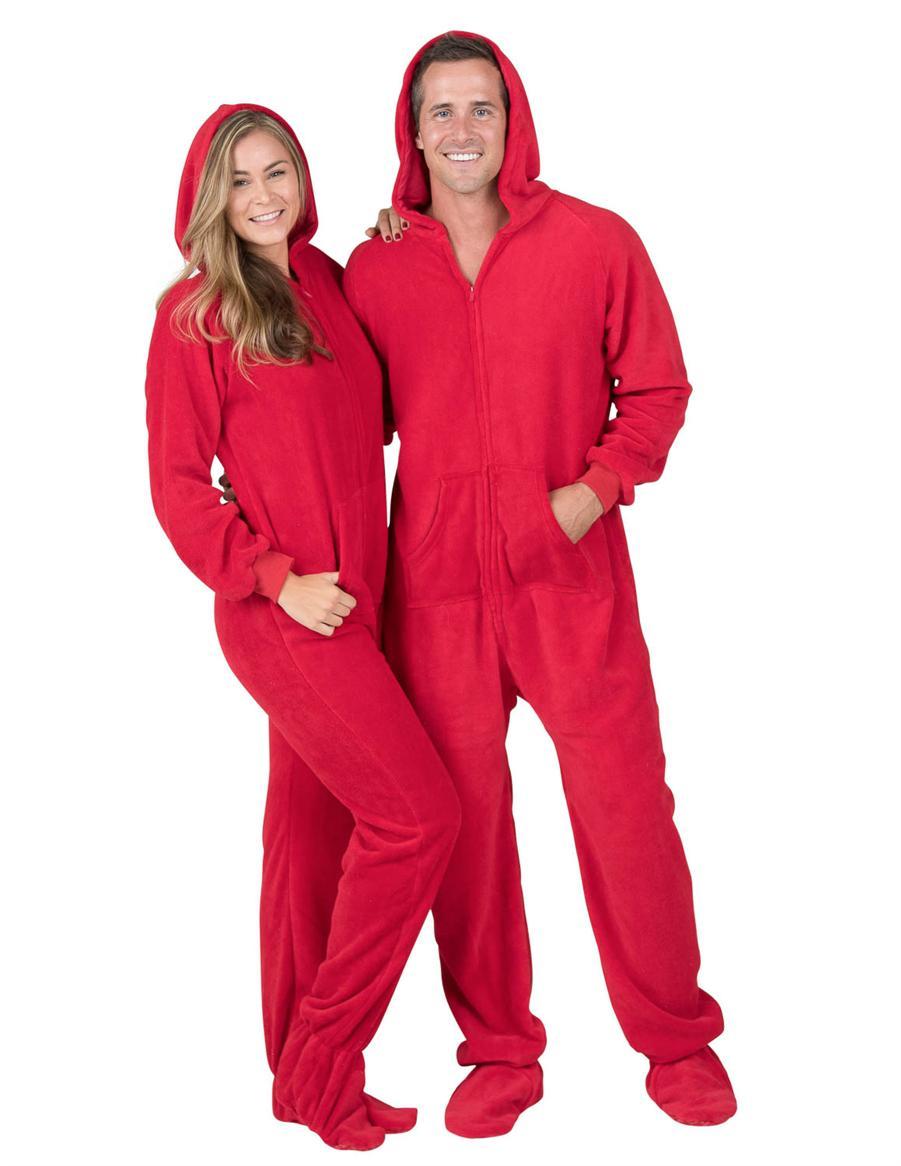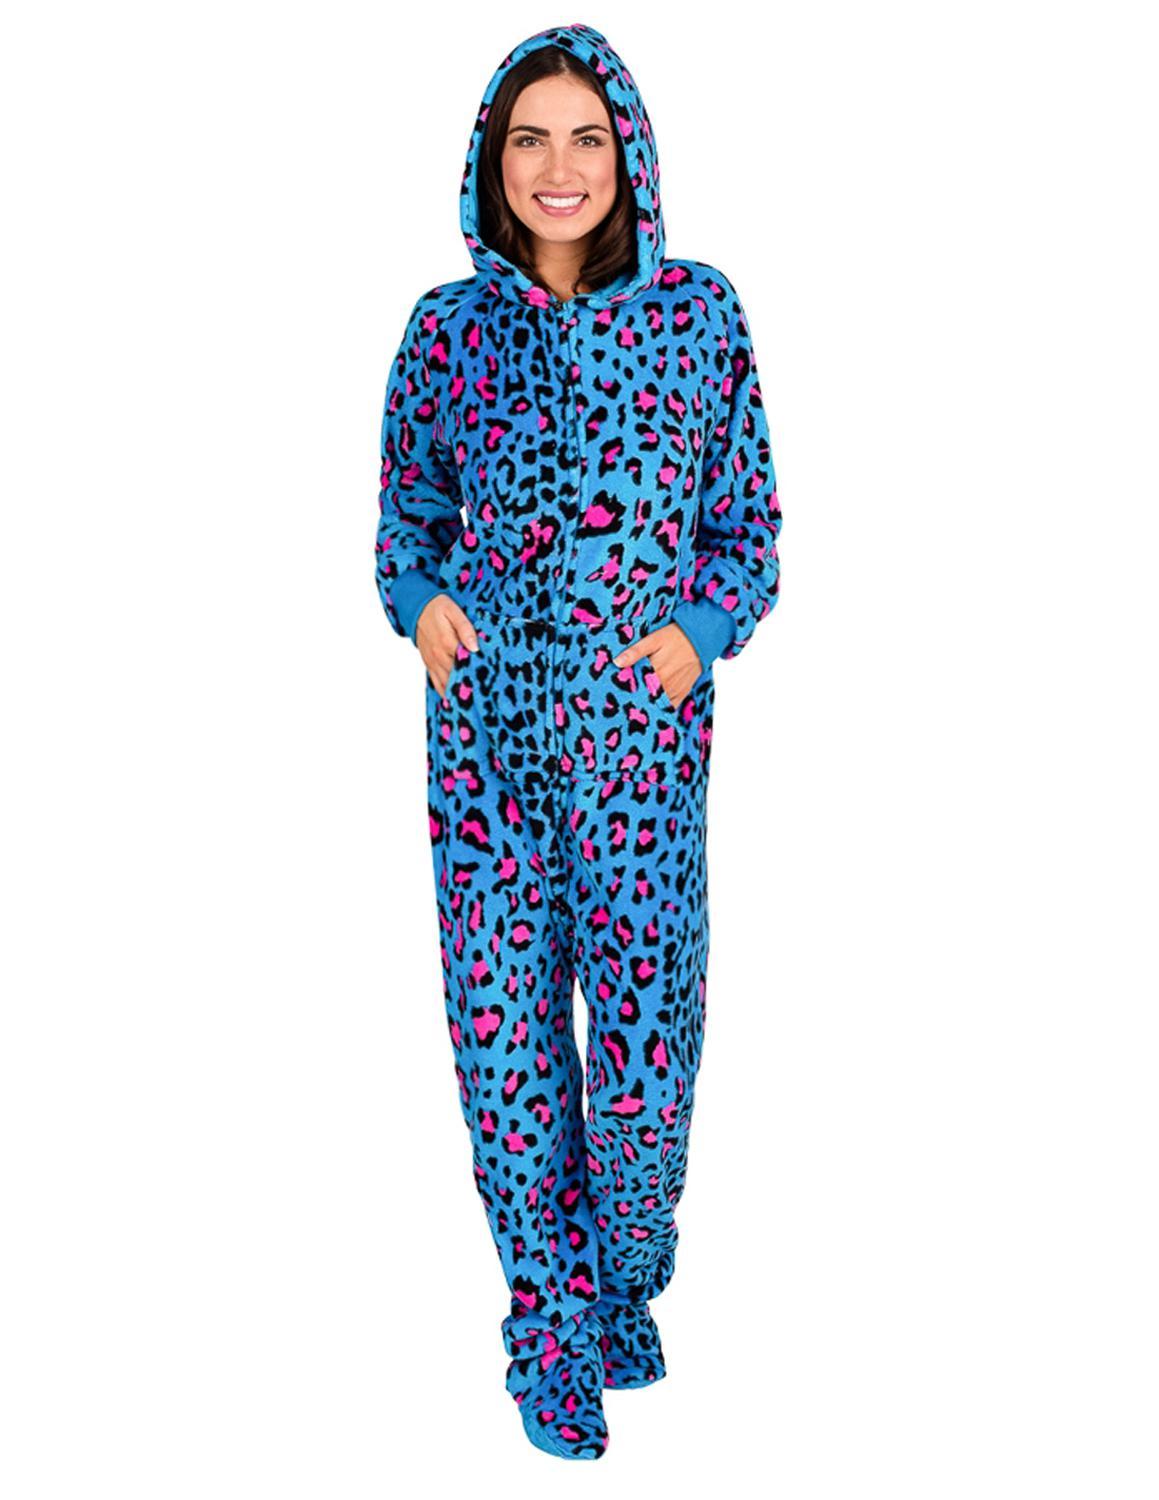The first image is the image on the left, the second image is the image on the right. Given the left and right images, does the statement "There is at least one person with their hood up." hold true? Answer yes or no. Yes. The first image is the image on the left, the second image is the image on the right. Examine the images to the left and right. Is the description "There are two female wearing pajamas by themselves" accurate? Answer yes or no. No. 